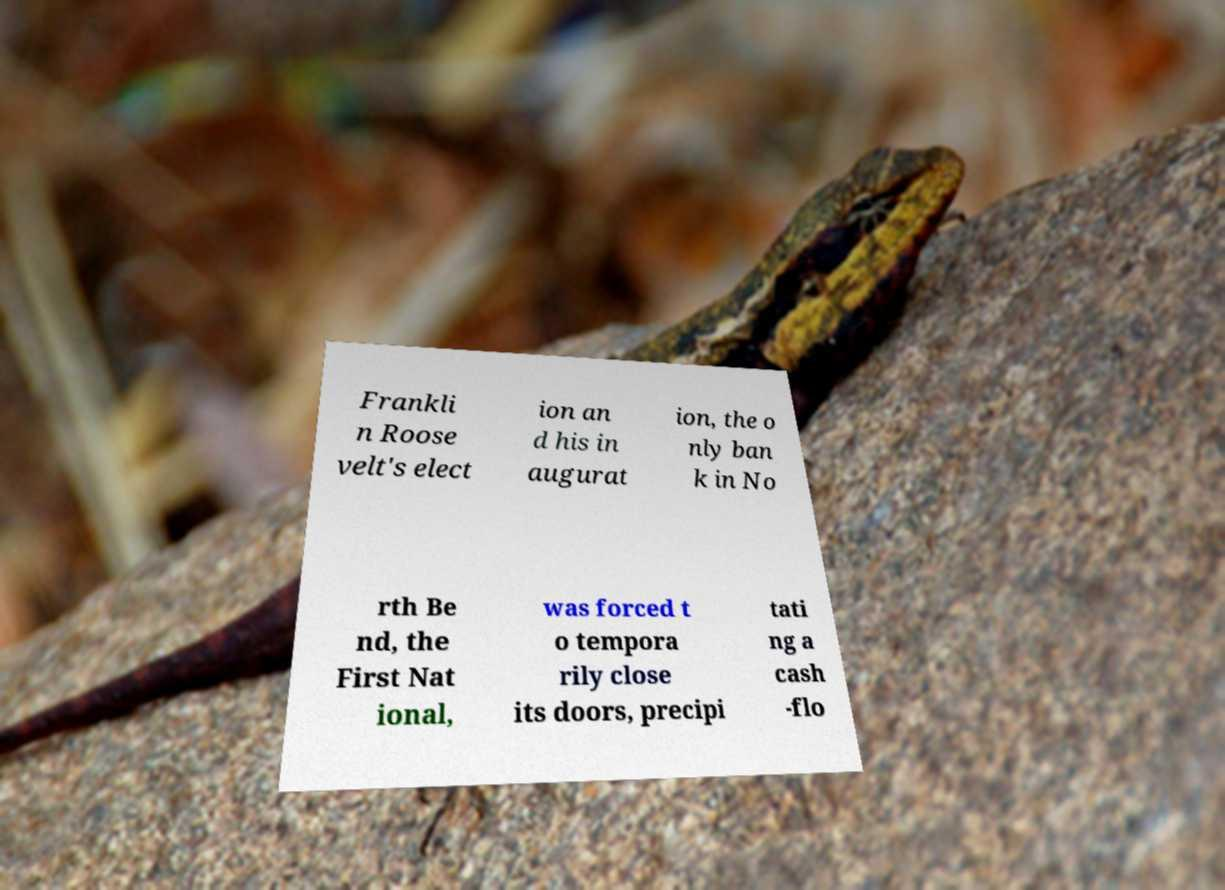Can you accurately transcribe the text from the provided image for me? Frankli n Roose velt's elect ion an d his in augurat ion, the o nly ban k in No rth Be nd, the First Nat ional, was forced t o tempora rily close its doors, precipi tati ng a cash -flo 